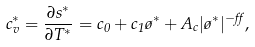<formula> <loc_0><loc_0><loc_500><loc_500>c ^ { \ast } _ { v } = \frac { \partial s ^ { \ast } } { \partial T ^ { \ast } } = c _ { 0 } + c _ { 1 } \tau ^ { \ast } + A _ { c } | \tau ^ { \ast } | ^ { - \alpha } ,</formula> 